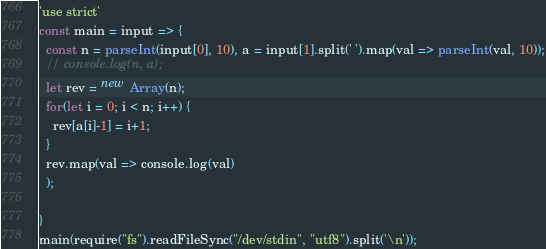<code> <loc_0><loc_0><loc_500><loc_500><_JavaScript_>'use strict'
const main = input => {
  const n = parseInt(input[0], 10), a = input[1].split(' ').map(val => parseInt(val, 10));
  // console.log(n, a);
  let rev = new Array(n);
  for(let i = 0; i < n; i++) {
    rev[a[i]-1] = i+1;
  }
  rev.map(val => console.log(val)
  );
  
}
main(require("fs").readFileSync("/dev/stdin", "utf8").split('\n'));</code> 